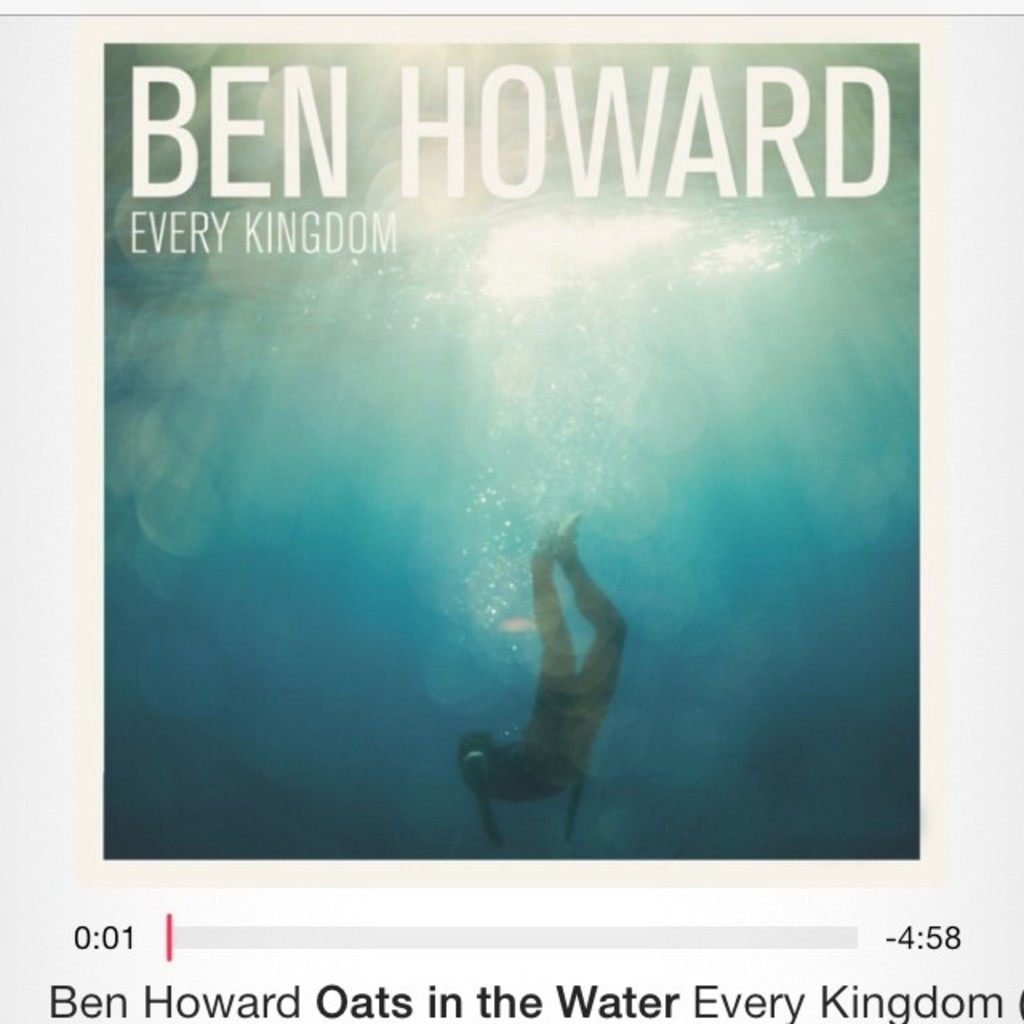How does the lighting in the image contribute to the overall mood of the album cover? The lighting in the image, emanating from above and bathing the diver in a celestial glow, plays a crucial role in setting the album cover's ethereal and soothing mood. It suggests a sense of descending into another world, which can be interpreted as a metaphor for immersion into the emotional or musical journey that the album promises. This lighting not only highlights the diver but also creates a serene and almost mystical atmosphere that complements the themes likely explored in the music. 